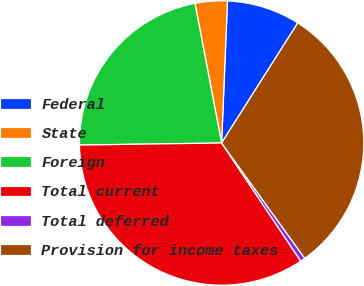Convert chart to OTSL. <chart><loc_0><loc_0><loc_500><loc_500><pie_chart><fcel>Federal<fcel>State<fcel>Foreign<fcel>Total current<fcel>Total deferred<fcel>Provision for income taxes<nl><fcel>8.34%<fcel>3.66%<fcel>22.23%<fcel>34.17%<fcel>0.55%<fcel>31.06%<nl></chart> 